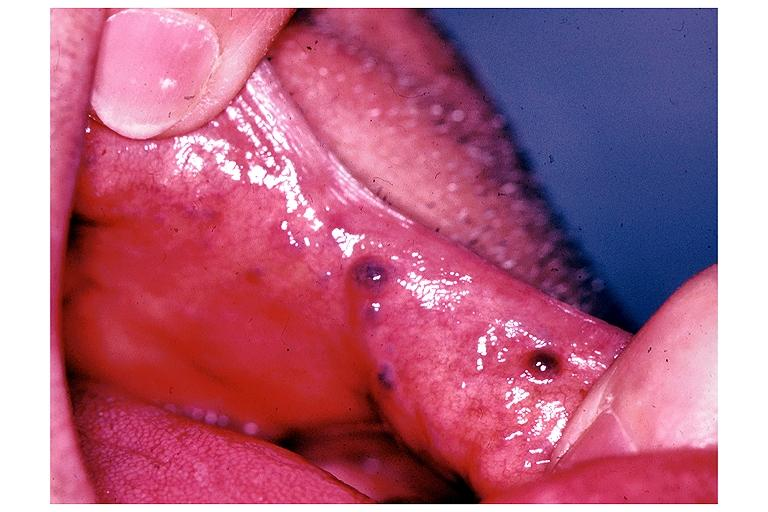where is this?
Answer the question using a single word or phrase. Oral 